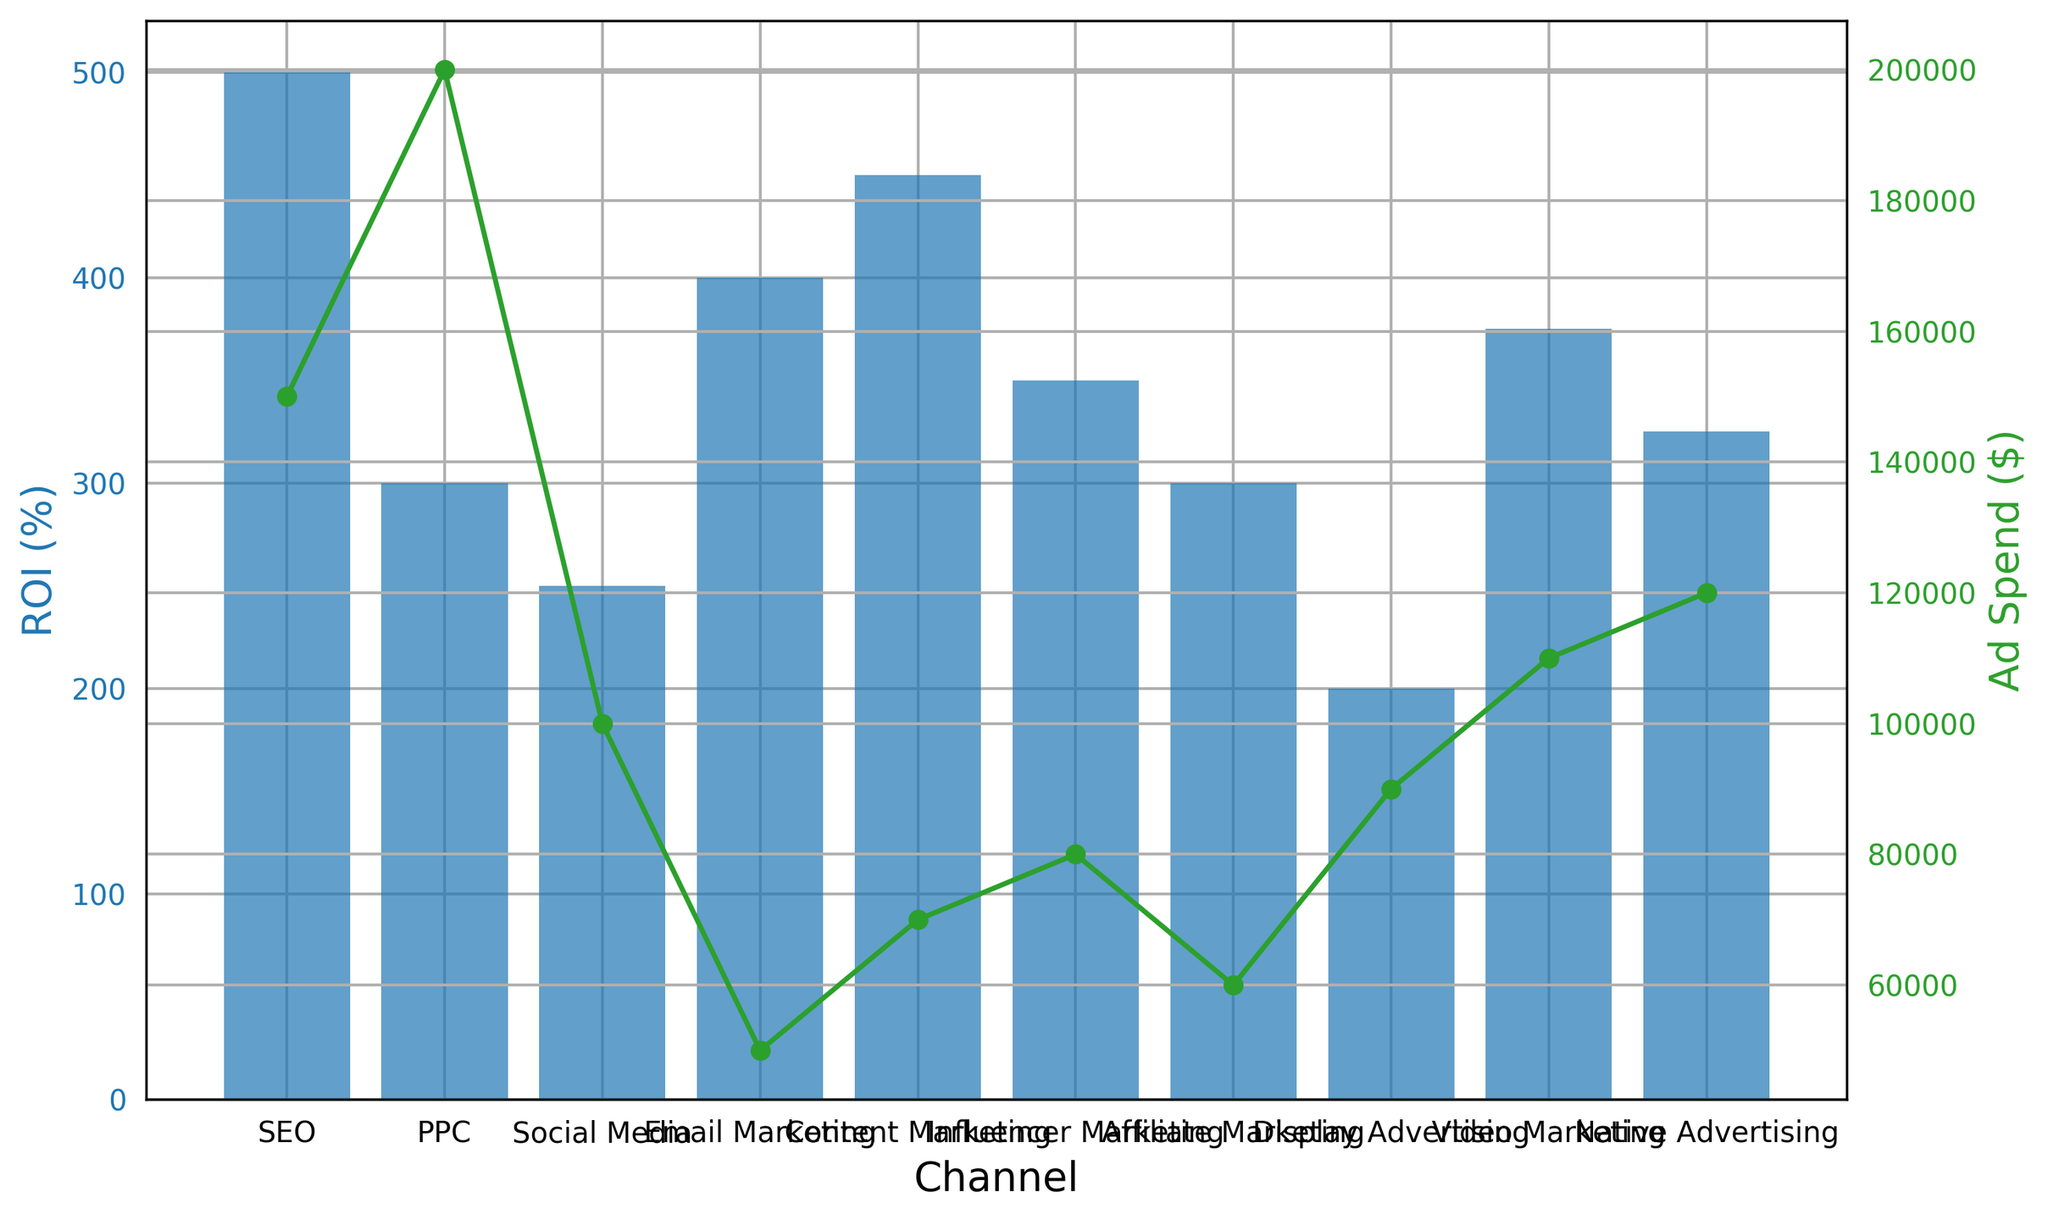What's the channel with the highest ROI? The highest ROI bar, which is blue, is associated with the 'SEO' channel, displaying a height corresponding to 500%.
Answer: SEO Which channel has the lowest Ad Spend? The green line plot for 'Email Marketing' reaches the lowest point on the right vertical axis, indicating the lowest Ad Spend of $50,000.
Answer: Email Marketing What is the difference in ROI between PPC and Video Marketing? PPC has an ROI of 300%, and Video Marketing has an ROI of 375%. The difference is calculated as 375% - 300%.
Answer: 75% If the total Ad Spend across all channels is summed up, what is the result? Sum up the ad spends for all channels: $150,000 (SEO) + $200,000 (PPC) + $100,000 (Social Media) + $50,000 (Email Marketing) + $70,000 (Content Marketing) + $80,000 (Influencer Marketing) + $60,000 (Affiliate Marketing) + $90,000 (Display Advertising) + $110,000 (Video Marketing) + $120,000 (Native Advertising).
Answer: $1,030,000 How does the height of the Content Marketing ROI bar compare to the Influencer Marketing ROI bar? The height of the ROI bar in blue for Content Marketing (450%) is higher than the Influencer Marketing ROI bar which stands at 350%.
Answer: Content Marketing has a higher bar Which channel has the highest Ad Spend? The green line for 'PPC' reaches the highest point on the right vertical axis, showing the highest Ad Spend of $200,000.
Answer: PPC What is the average ROI of Email Marketing and Affiliate Marketing? Calculate the average of their ROIs: (400% (Email Marketing) + 300% (Affiliate Marketing)) / 2 = 350%.
Answer: 350% Is Native Advertising's ROI greater than Display Advertising's ROI? The height of Native Advertising ROI (325%) bar is greater than Display Advertising ROI bar which corresponds to 200%.
Answer: Yes What is the sum of the ROI percentages for all channels? Sum up the ROI percentages: 500% (SEO) + 300% (PPC) + 250% (Social Media) + 400% (Email Marketing) + 450% (Content Marketing) + 350% (Influencer Marketing) + 300% (Affiliate Marketing) + 200% (Display Advertising) + 375% (Video Marketing) + 325% (Native Advertising).
Answer: 3450% Between Content Marketing and Video Marketing, which has the higher Ad Spend? The green line marker for Video Marketing is higher than that for Content Marketing, indicating Video Marketing has higher Ad Spend ($110,000 vs. $70,000).
Answer: Video Marketing 